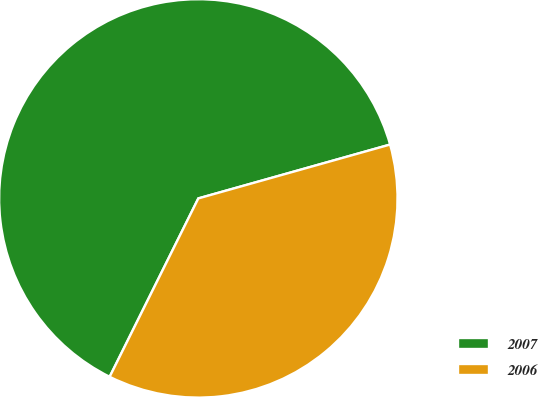Convert chart to OTSL. <chart><loc_0><loc_0><loc_500><loc_500><pie_chart><fcel>2007<fcel>2006<nl><fcel>63.3%<fcel>36.7%<nl></chart> 